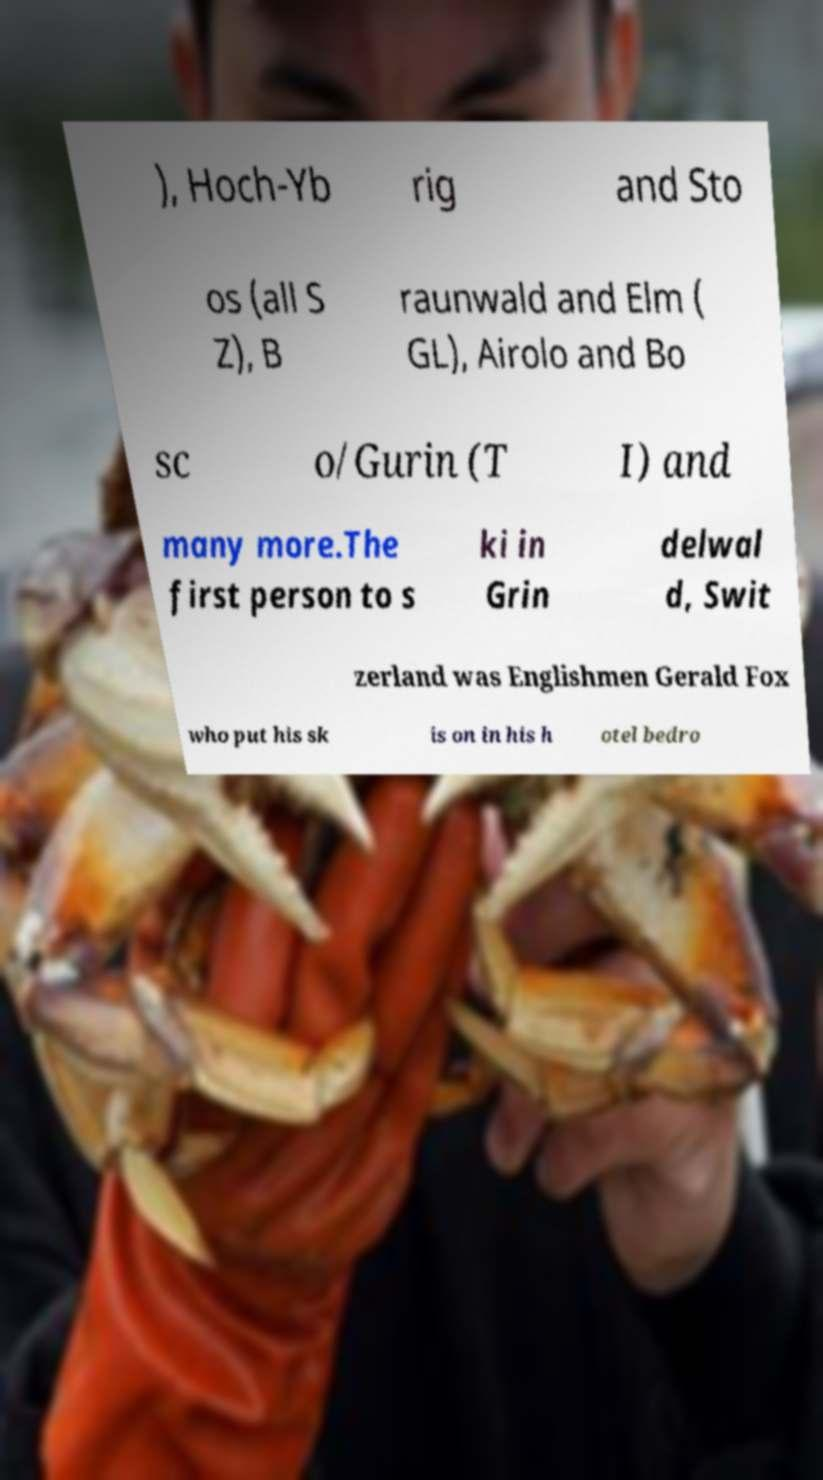What messages or text are displayed in this image? I need them in a readable, typed format. ), Hoch-Yb rig and Sto os (all S Z), B raunwald and Elm ( GL), Airolo and Bo sc o/Gurin (T I) and many more.The first person to s ki in Grin delwal d, Swit zerland was Englishmen Gerald Fox who put his sk is on in his h otel bedro 